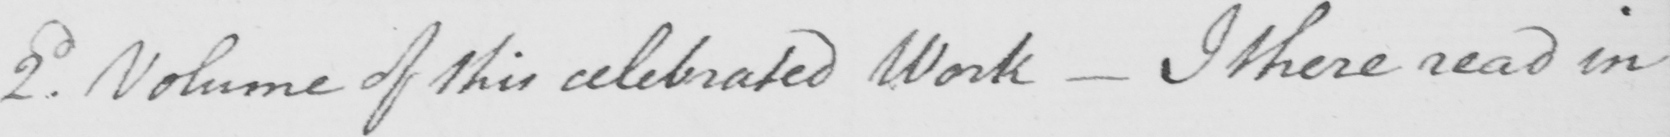Please transcribe the handwritten text in this image. 2.d Volume of this celebrated Work  _  I there read in 